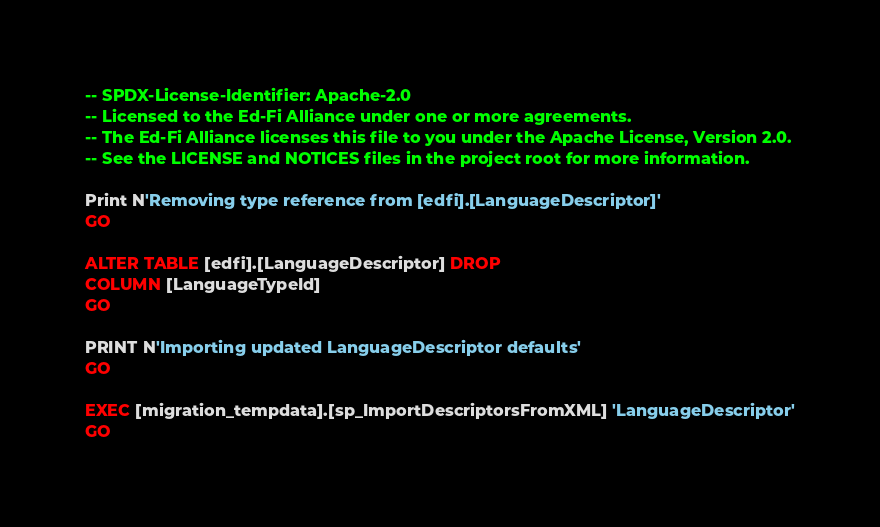Convert code to text. <code><loc_0><loc_0><loc_500><loc_500><_SQL_>-- SPDX-License-Identifier: Apache-2.0
-- Licensed to the Ed-Fi Alliance under one or more agreements.
-- The Ed-Fi Alliance licenses this file to you under the Apache License, Version 2.0.
-- See the LICENSE and NOTICES files in the project root for more information.

Print N'Removing type reference from [edfi].[LanguageDescriptor]'
GO

ALTER TABLE [edfi].[LanguageDescriptor] DROP
COLUMN [LanguageTypeId]
GO

PRINT N'Importing updated LanguageDescriptor defaults'
GO

EXEC [migration_tempdata].[sp_ImportDescriptorsFromXML] 'LanguageDescriptor'
GO
</code> 